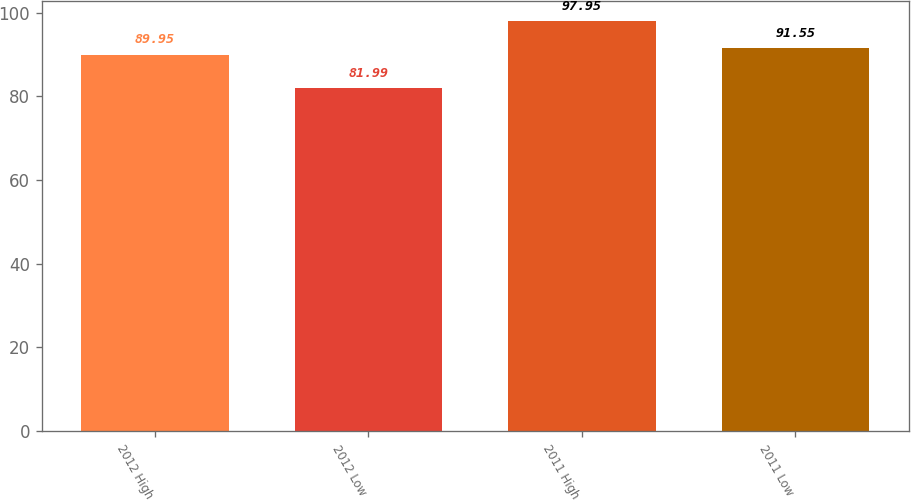Convert chart to OTSL. <chart><loc_0><loc_0><loc_500><loc_500><bar_chart><fcel>2012 High<fcel>2012 Low<fcel>2011 High<fcel>2011 Low<nl><fcel>89.95<fcel>81.99<fcel>97.95<fcel>91.55<nl></chart> 